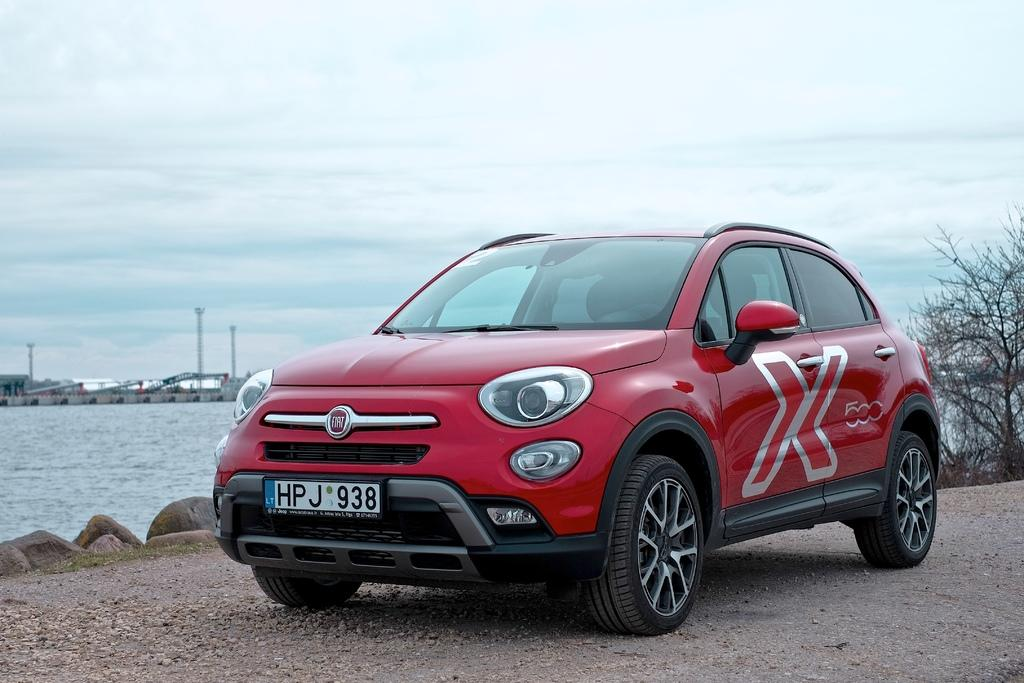What color is the car in the image? The car in the image is red in the image. Where is the car located in the image? The car is on the ground in the image. What can be seen in the background of the image? There is a tree, water, poles, and the sky visible in the background of the image. How much sugar is in the car's gas tank in the image? There is no information about sugar or a gas tank in the image, as it features a red car on the ground with a background containing a tree, water, poles, and the sky. 